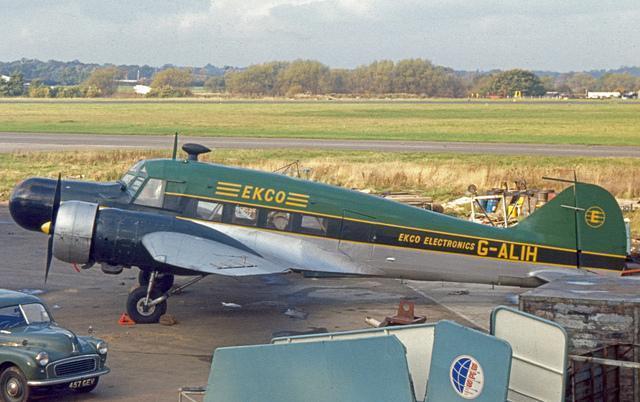How many people are wearing flip flops?
Give a very brief answer. 0. 